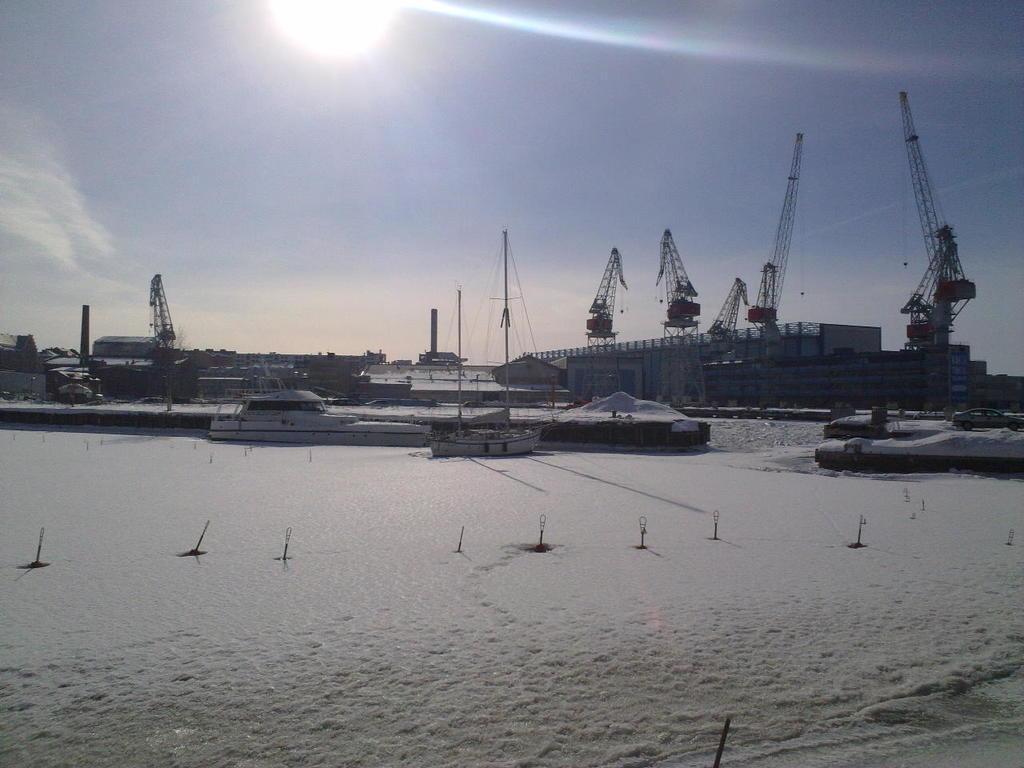Please provide a concise description of this image. In this image there is a ship and a boat on the snow. A vehicle is on the road. There are few cranes. Behind there are few buildings. Top of image there is sky having a son. 